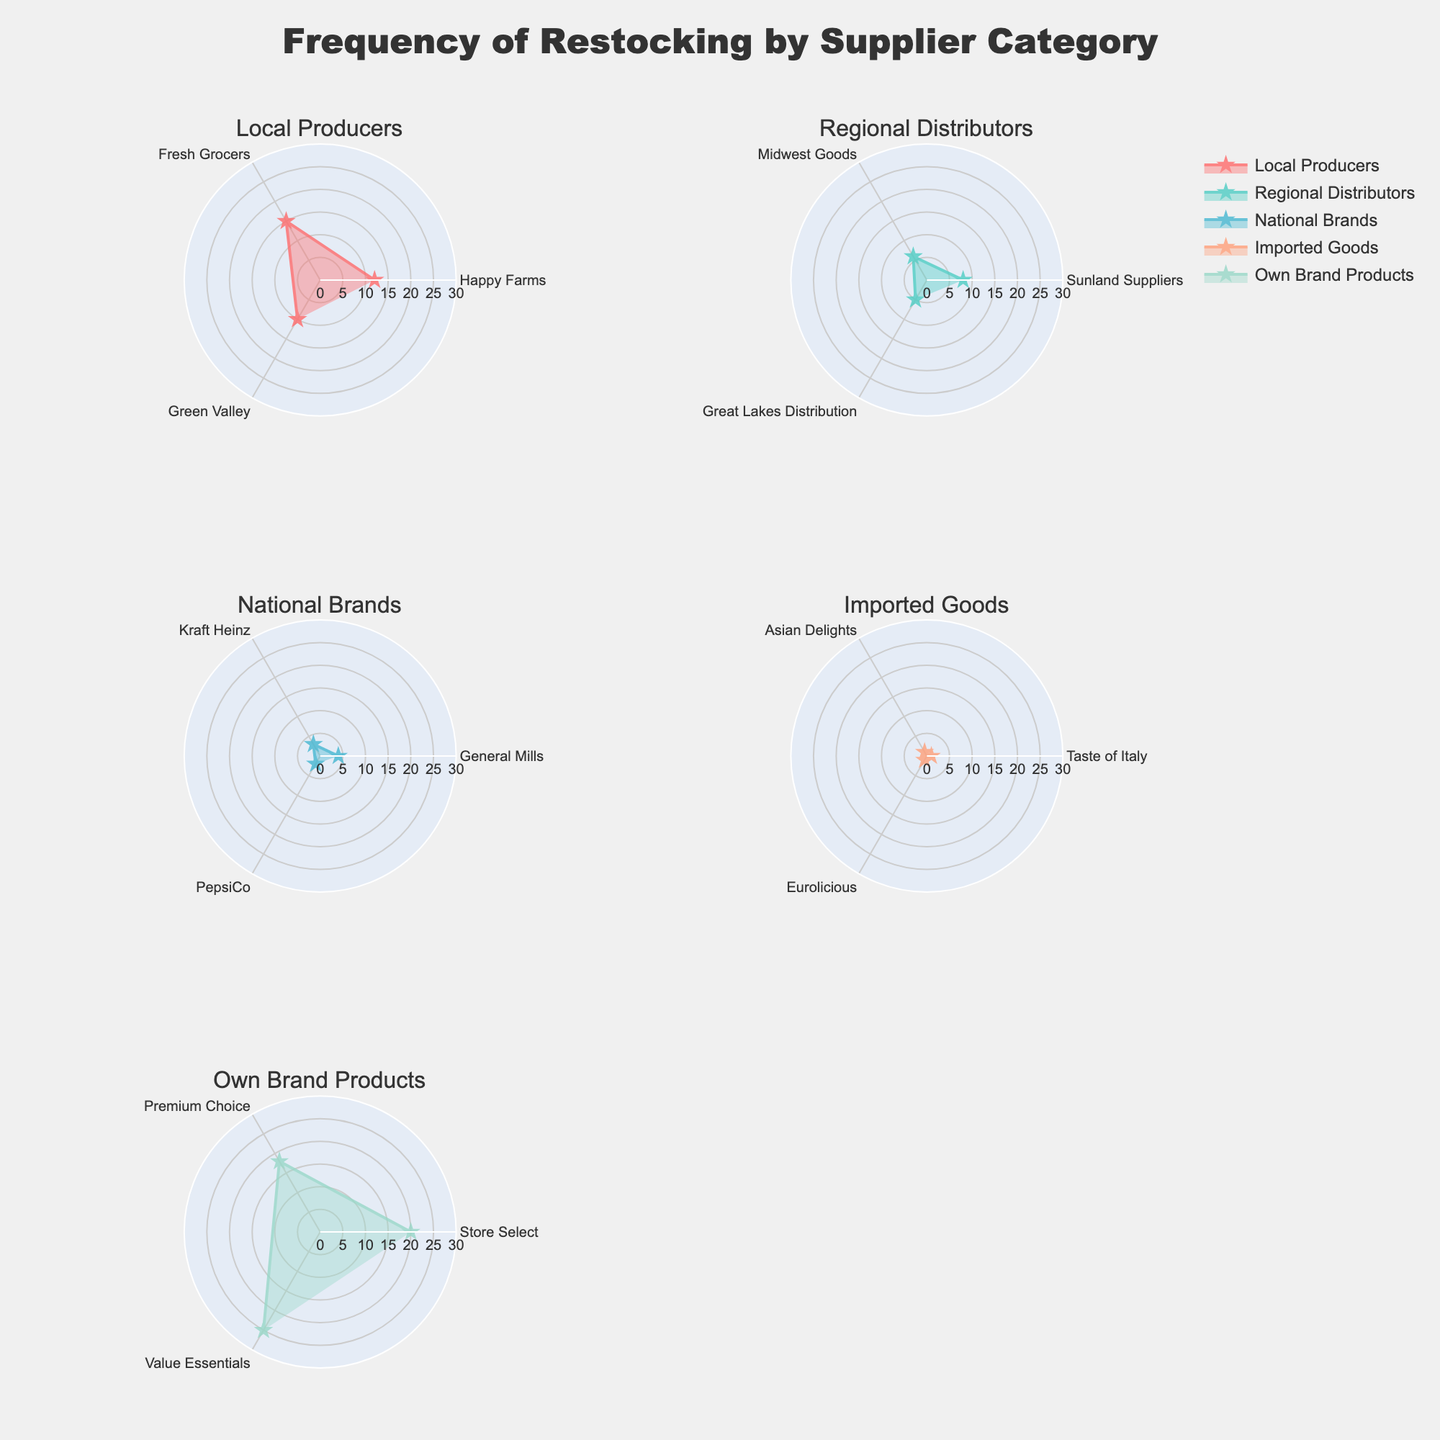what is the restocking frequency for "Premium Choice" under "Own Brand Products"? First, locate the subplot titled "Own Brand Products". In this polar plot, find the point labelled "Premium Choice". The frequency associated with "Premium Choice" can be read directly from the radial axis.
Answer: 18 which supplier has the highest restocking frequency overall? To determine the supplier with the highest restocking frequency, examine all subplots and compare the radial distances of the points. The supplier with the maximum value on the radial axis across all subplots is "Value Essentials" in the "Own Brand Products" category.
Answer: Value Essentials how many suppliers have a restocking frequency of 1? Count the number of points in all subplots where the radial value is 1. These suppliers are "Taste of Italy", "Asian Delights", and "Eurolicious" under "Imported Goods".
Answer: 3 what is the average frequency of restocking for "Local Producers"? Locate the subplot titled "Local Producers" and sum the frequencies: (12 + 15 + 10). There are 3 suppliers, so divide the total by 3. The average is (12 + 15 + 10)/3 = 37/3 = 12.33
Answer: 12.33 is the restocking frequency for "Midwest Goods" greater than that for "Great Lakes Distribution"? Locate the subplot titled "Regional Distributors". In this subplot, compare the radial distances of the points labelled "Midwest Goods" and "Great Lakes Distribution". "Midwest Goods" has a frequency of 6, while "Great Lakes Distribution" has a frequency of 5.
Answer: Yes which category has the lowest average restocking frequency? Calculate the average restocking frequency for each category. "Local Producers" averages 12.33, "Regional Distributors" averages (8 + 6 + 5)/3 = 6.33, "National Brands" averages (4 + 3 + 2)/3 = 3, "Imported Goods" averages (1 + 1 + 1)/3 = 1, and "Own Brand Products" averages (20 + 18 + 25)/3 = 21. The category with the lowest average is "Imported Goods".
Answer: Imported Goods what is the difference in restocking frequencies between "Happy Farms" and "Fresh Grocers"? In the subplot titled "Local Producers", note the frequencies for "Happy Farms" (12) and "Fresh Grocers" (15). Subtract the smaller frequency from the larger one: 15 - 12 = 3.
Answer: 3 which category has the widest range of restocking frequencies? Calculate the range (max - min frequency) for each category. "Local Producers" range is 15 - 10 = 5, "Regional Distributors" range is 8 - 5 = 3, "National Brands" range is 4 - 2 = 2, "Imported Goods" range is 1 - 1 = 0, and "Own Brand Products" range is 25 - 18 = 7. The category with the widest range is "Own Brand Products".
Answer: Own Brand Products 